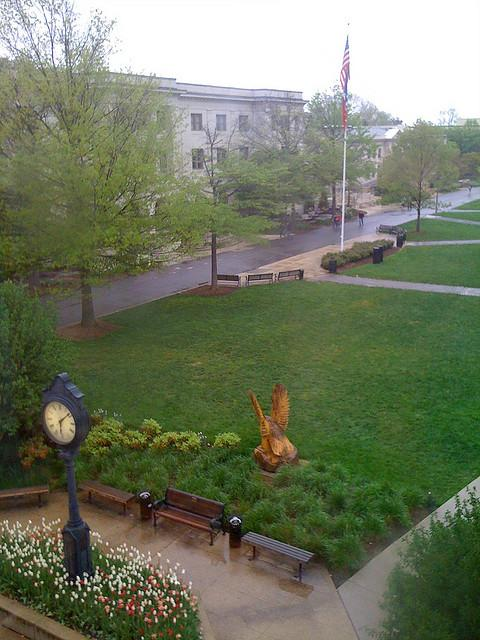What might someone need if they are walking by this clock? umbrella 